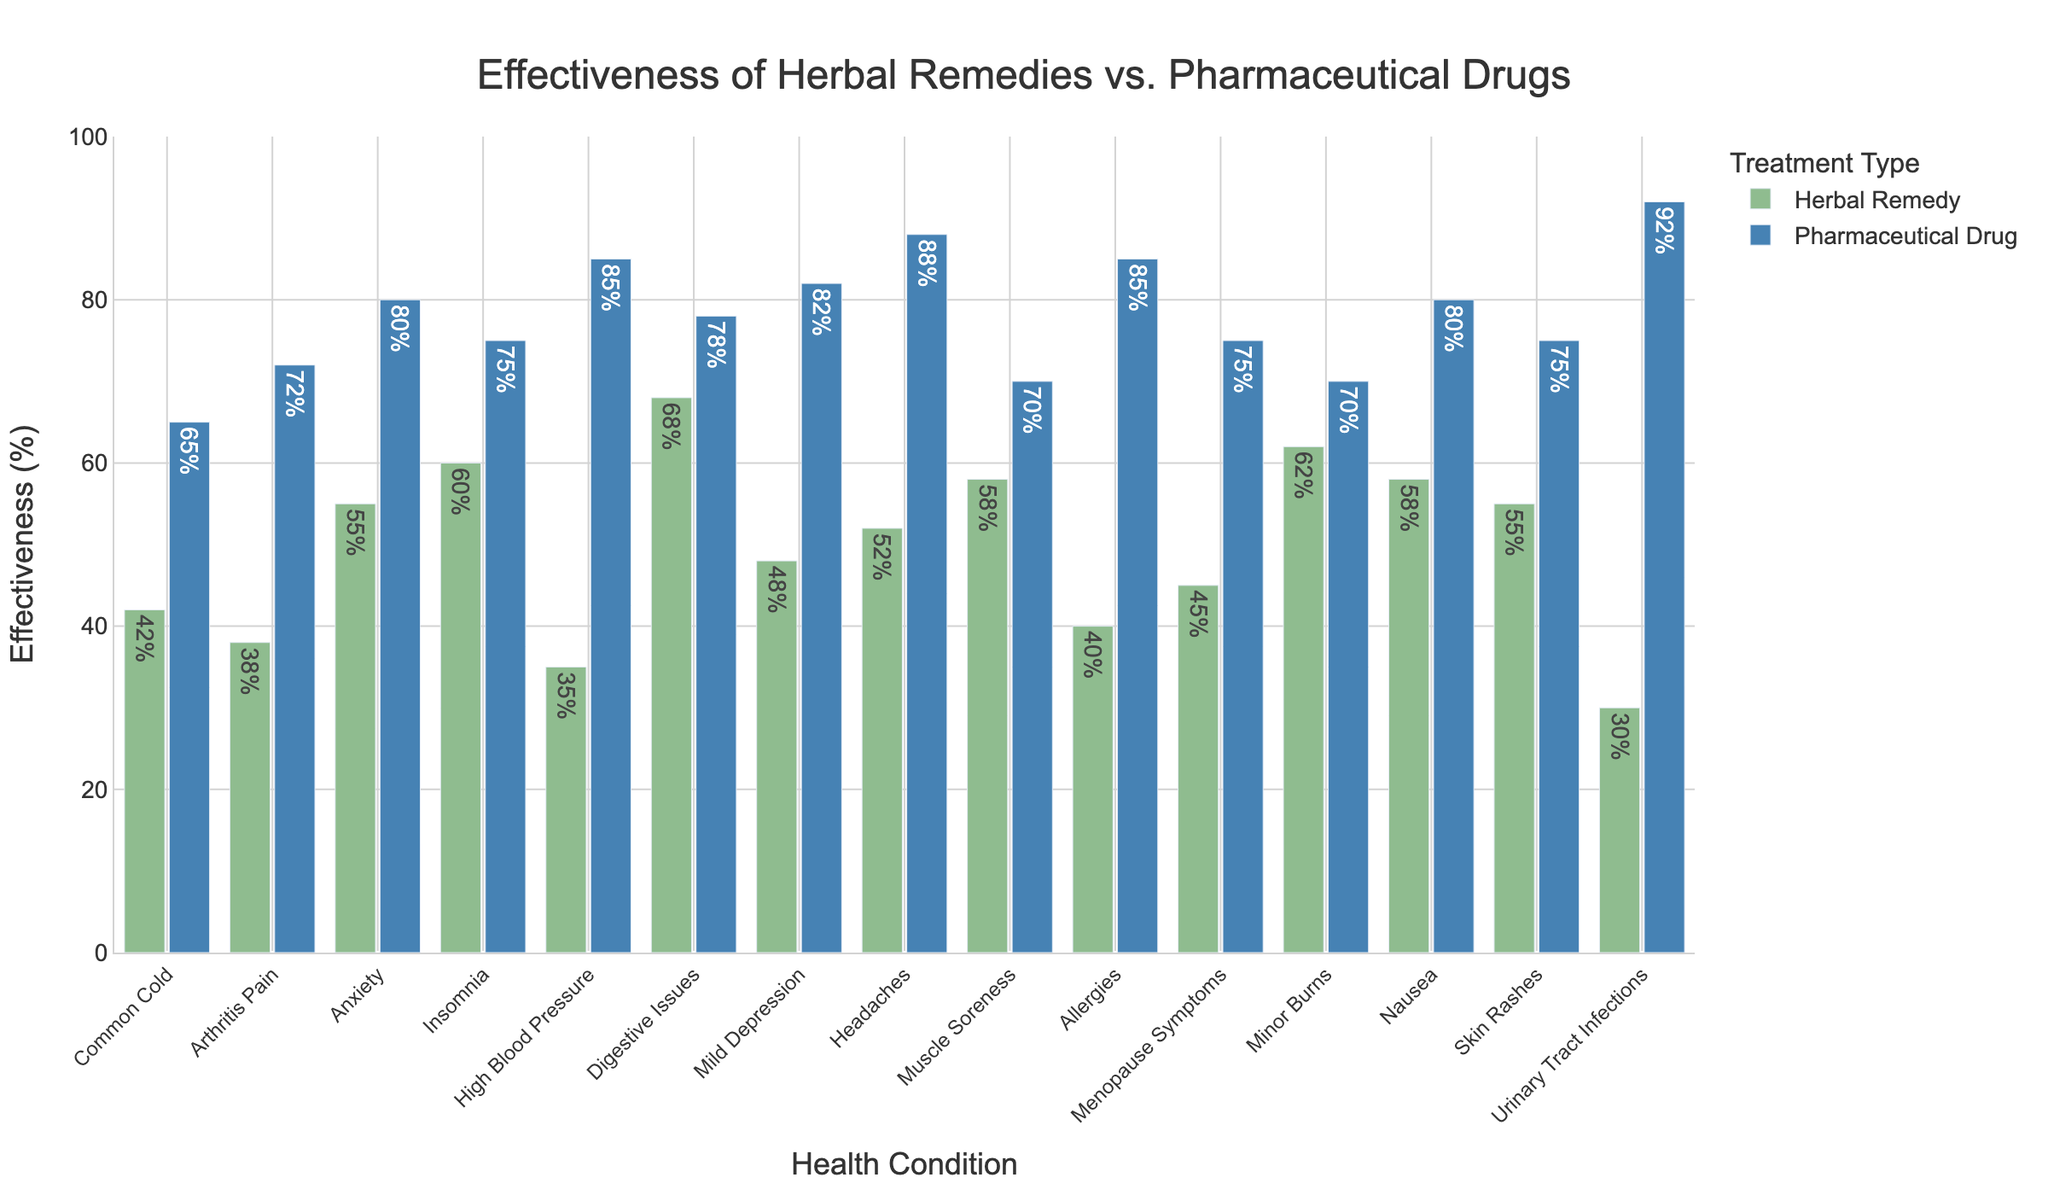Which condition shows the highest effectiveness for pharmaceutical drugs? Look for the tallest blue bar in the chart, which corresponds to Urinary Tract Infections, showing the highest pharmaceutical drug effectiveness.
Answer: Urinary Tract Infections Which condition has a higher effectiveness of herbal remedies than pharmaceutical drugs? Compare the heights of the green and blue bars for each condition; Digestive Issues show that the herbal remedy effectiveness is higher (68%) than pharmaceutical drugs (78%).
Answer: Digestive Issues What is the difference in effectiveness between herbal remedies and pharmaceutical drugs for treating anxiety? Find the blue bar height (80%) and the green bar height (55%) for Anxiety, and subtract the two values (80 - 55).
Answer: 25% On average, how effective are herbal remedies for the listed conditions? Add the effectiveness percentages of herbal remedies for all conditions and divide by the number of conditions (15). (42+38+55+60+35+68+48+52+58+40+45+62+58+55+30) = 696; 696/15 = 46.4%.
Answer: 46.4% For which conditions are the effectiveness rates of herbal remedies and pharmaceutical drugs exactly 20 percent apart? Look for conditions where the difference between the blue and green bar heights is exactly 20 (e.g., Insomnia, Nausea, and Skin Rashes).
Answer: Insomnia, Nausea, Skin Rashes What is the total effectiveness rate of pharmaceutical drugs for conditions affecting the nervous system (Anxiety, Insomnia, Mild Depression, and Headaches)? Add the pharmaceutical drug effectiveness rates for Anxiety (80%), Insomnia (75%), Mild Depression (82%), and Headaches (88%). 80+75+82+88 = 325.
Answer: 325% In how many conditions do herbal remedies have an effectiveness rate greater than 50%? Count the number of green bars with heights greater than 50%, which corresponds to five conditions (Insomnia, Digestive Issues, Mild Depression, Muscle Soreness, Nausea, Skin Rashes).
Answer: 6 What is the combined effectiveness rate of herbal remedies and pharmaceutical drugs for Minor Burns? Add the effectiveness rates for both treatments for Minor Burns (62% herbal remedies and 70% pharmaceutical drugs). 62+70 = 132.
Answer: 132% Does any condition show equal effectiveness between herbal remedies and pharmaceutical drugs? Check for any pair of green and blue bars that are of equal height. In this dataset, all pairs are of different heights.
Answer: No Which treatment shows the least variation in effectiveness across all conditions? Visually assess the consistency in bar heights for both herbal remedies and pharmaceutical drugs across all conditions. The pharmaceutical drugs show more consistent heights.
Answer: Pharmaceutical Drugs 